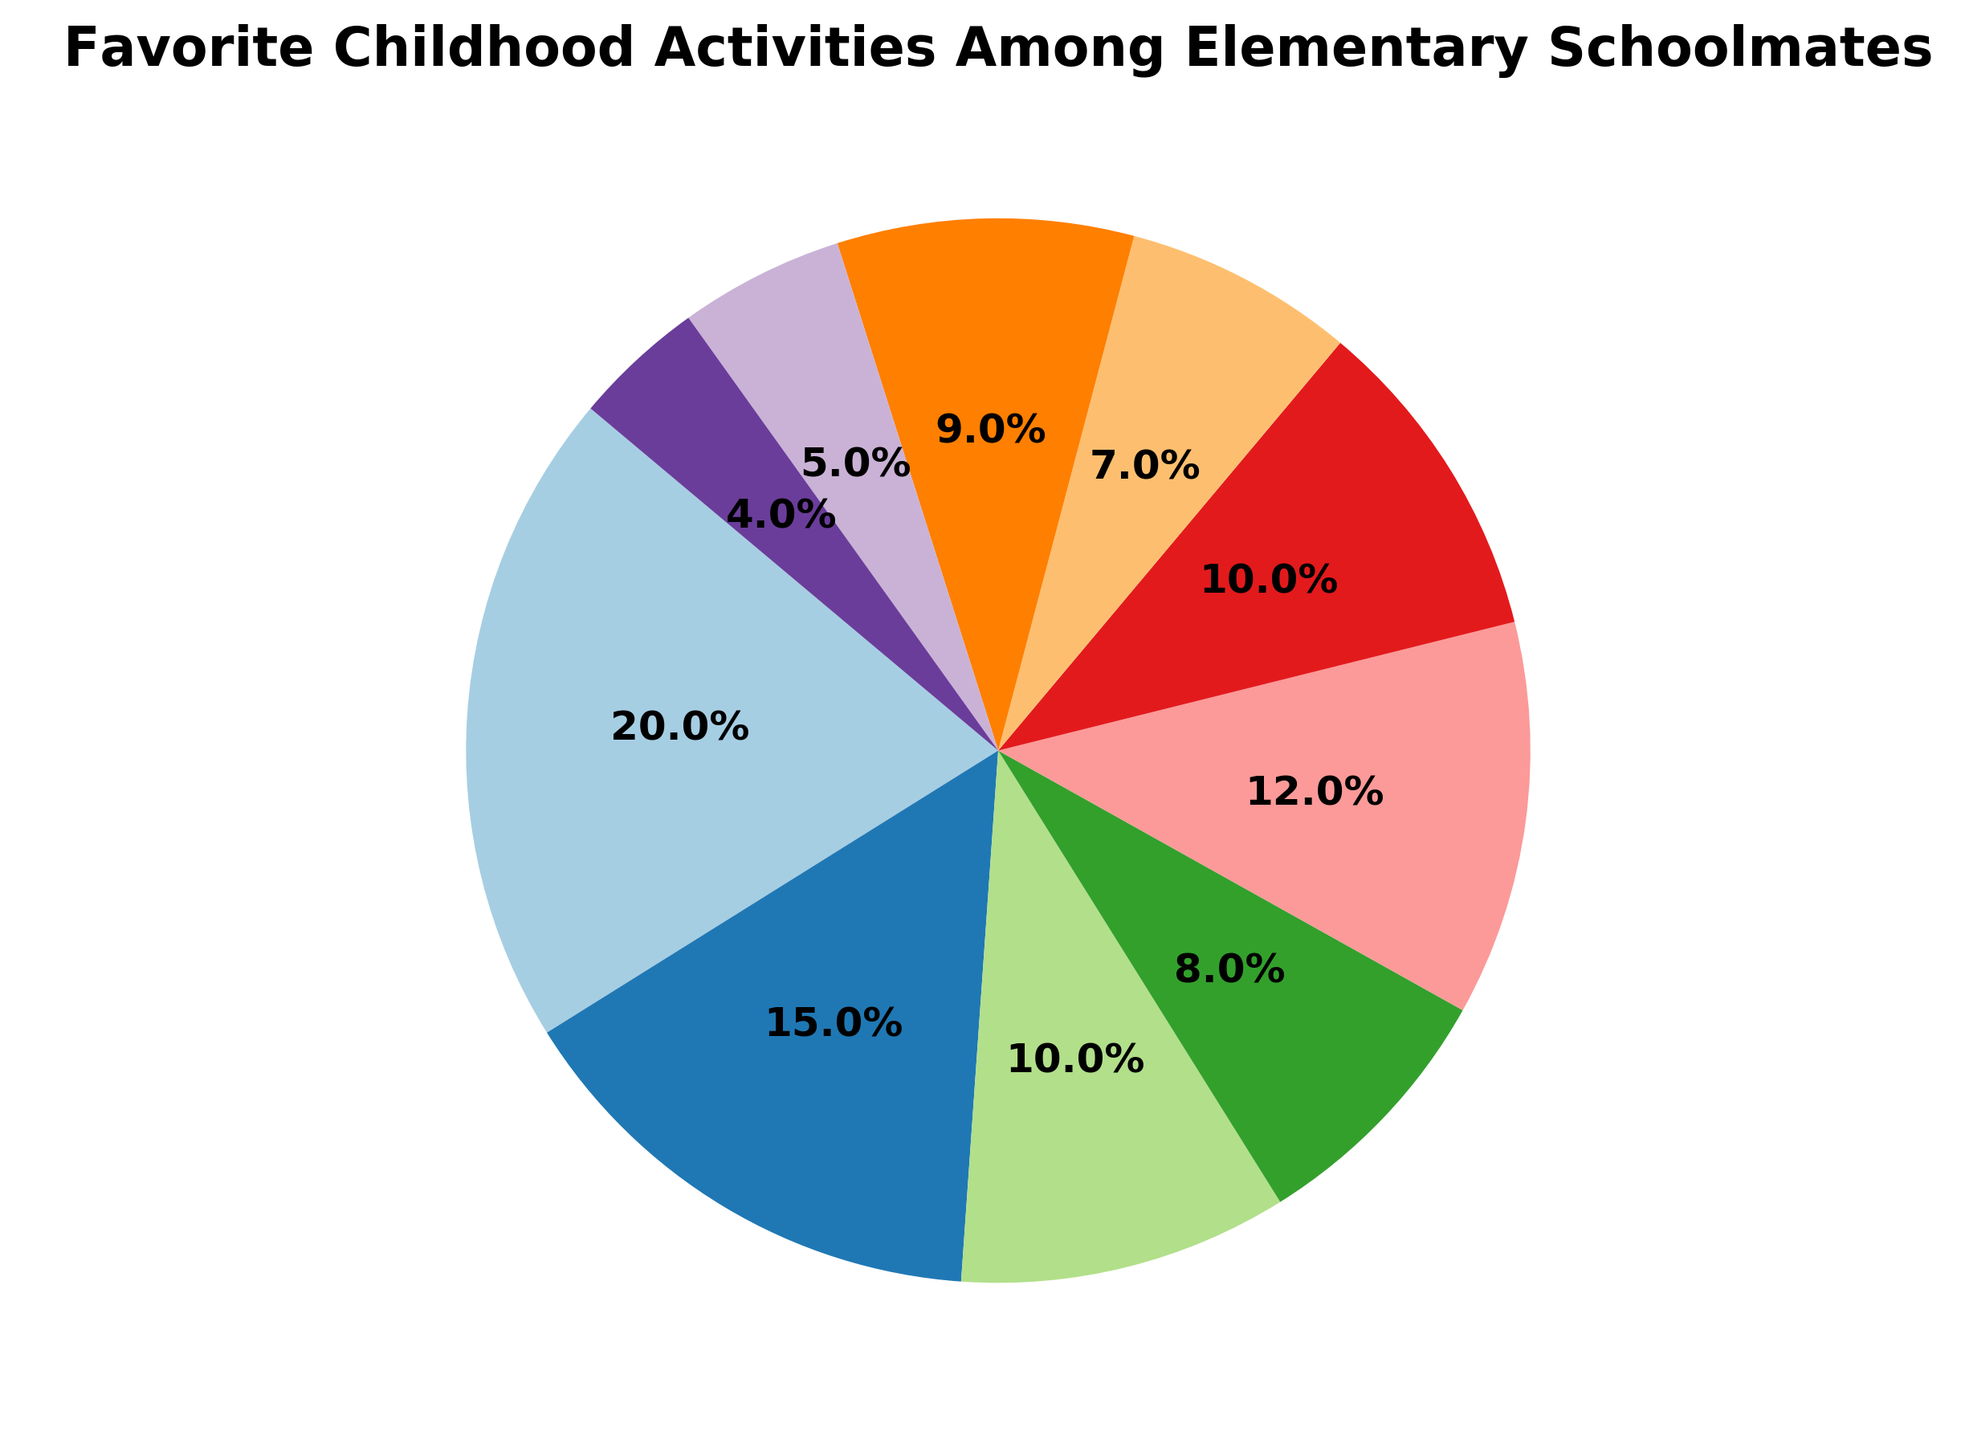What's the most popular childhood activity among elementary schoolmates? First, identify the activity with the highest percentage. The activity with 20% is "Playing Tag", which is the highest percentage on the chart.
Answer: Playing Tag What is the combined percentage of "Dodgeball" and "Kickball"? Add the individual percentages of "Dodgeball" (10%) and "Kickball" (5%) together. The combined percentage is 10% + 5% = 15%.
Answer: 15% Which activity is least popular among elementary schoolmates? Identify the activity with the lowest percentage. "Collecting Trading Cards" has the lowest percentage of 4% on the chart.
Answer: Collecting Trading Cards How many activities have a higher percentage than "Reading Stories"? "Reading Stories" has a percentage of 8%. Count the activities with percentages higher than 8%. They are "Playing Tag" (20%), "Hide and Seek" (15%), "Arts and Crafts" (12%), and "Dodgeball" (10%). That's four activities.
Answer: 4 Are there any activities with equal percentages? If so, which ones? Look for activities that share the same percentage values. "Dodgeball" and "Watching Cartoons" both have 10%.
Answer: Dodgeball and Watching Cartoons What is the total percentage of activities related to sports (Playing Tag, Dodgeball, Kickball)? Sum the percentages of "Playing Tag" (20%), "Dodgeball" (10%), and "Kickball" (5%). The total is 20% + 10% + 5% = 35%.
Answer: 35% Which two activities together make up a quarter (25%) of the pie chart? First, review the percentages of each activity. Then find the combinations that add up to 25%. "Hide and Seek" (15%) and "Arts and Crafts" (12%) together almost make a quarter, but they sum to 27%. A better match could be "Playing Tag" (20%) and "Collecting Trading Cards" (4%), but they sum to 24%. The combination "Swinging on the Playground" (9%) and "Dodgeball" (10%) with "Board Games" (7%) = 26%. No exact combination matches 25%.
Answer: None exactly Which activity has a percentage closest to twice that of "Swinging on the Playground"? "Swinging on the Playground" has 9%, twice of which is 18%. The closest percentage to 18% is "Hide and Seek" with 15%.
Answer: Hide and Seek What are the percentages of non-sport activities combined? Non-sport activities include: Reading Stories (8%), Arts and Crafts (12%), Watching Cartoons (10%), Board Games (7%), Swinging on the Playground (9%), and Collecting Trading Cards (4%). The combined percentage is 8% + 12% + 10% + 7% + 9% + 4% = 50%.
Answer: 50% If the percentages are rounded to the nearest whole number, does the total percentage still sum to 100%? Round each percentage to the nearest whole number: Playing Tag (20%), Hide and Seek (15%), Dodgeball (10%), Reading Stories (8%), Arts and Crafts (12%), Watching Cartoons (10%), Board Games (7%), Swinging on the Playground (9%), Kickball (5%), Collecting Trading Cards (4%). The rounded percentages still add up to 100% as these values hold their nearest whole values intact.
Answer: Yes 